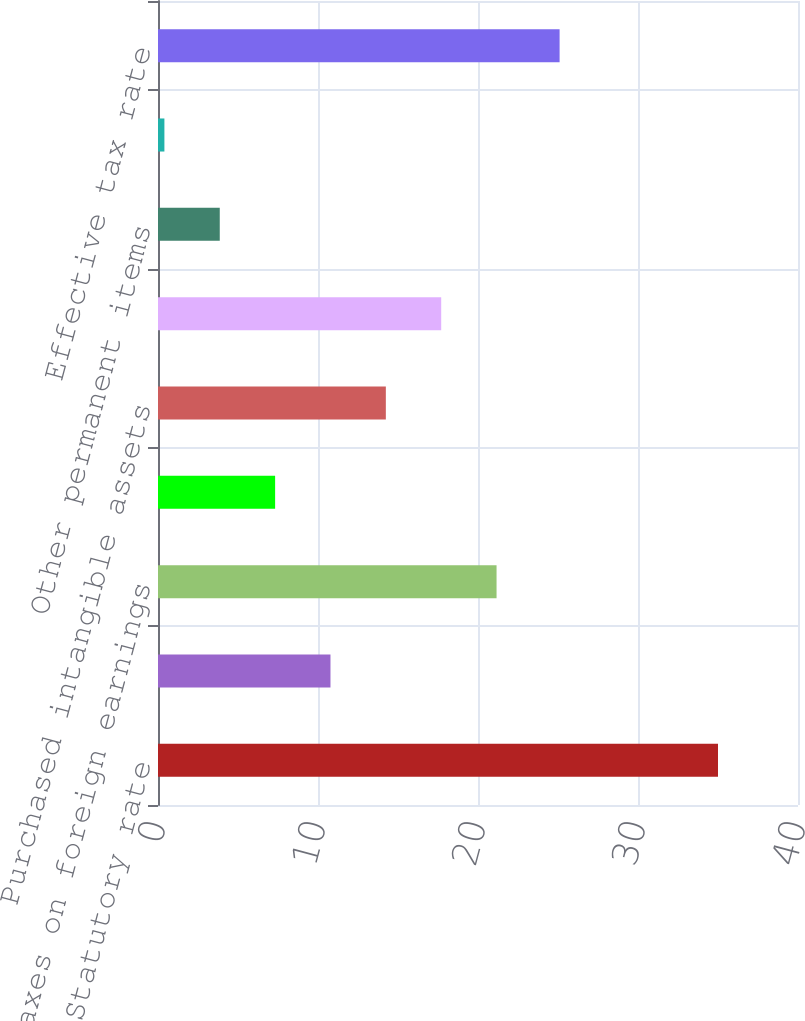Convert chart. <chart><loc_0><loc_0><loc_500><loc_500><bar_chart><fcel>Statutory rate<fcel>State taxes<fcel>Taxes on foreign earnings<fcel>Credits and net operating loss<fcel>Purchased intangible assets<fcel>Manufacturing deduction<fcel>Other permanent items<fcel>Other<fcel>Effective tax rate<nl><fcel>35<fcel>10.78<fcel>21.16<fcel>7.32<fcel>14.24<fcel>17.7<fcel>3.86<fcel>0.4<fcel>25.1<nl></chart> 